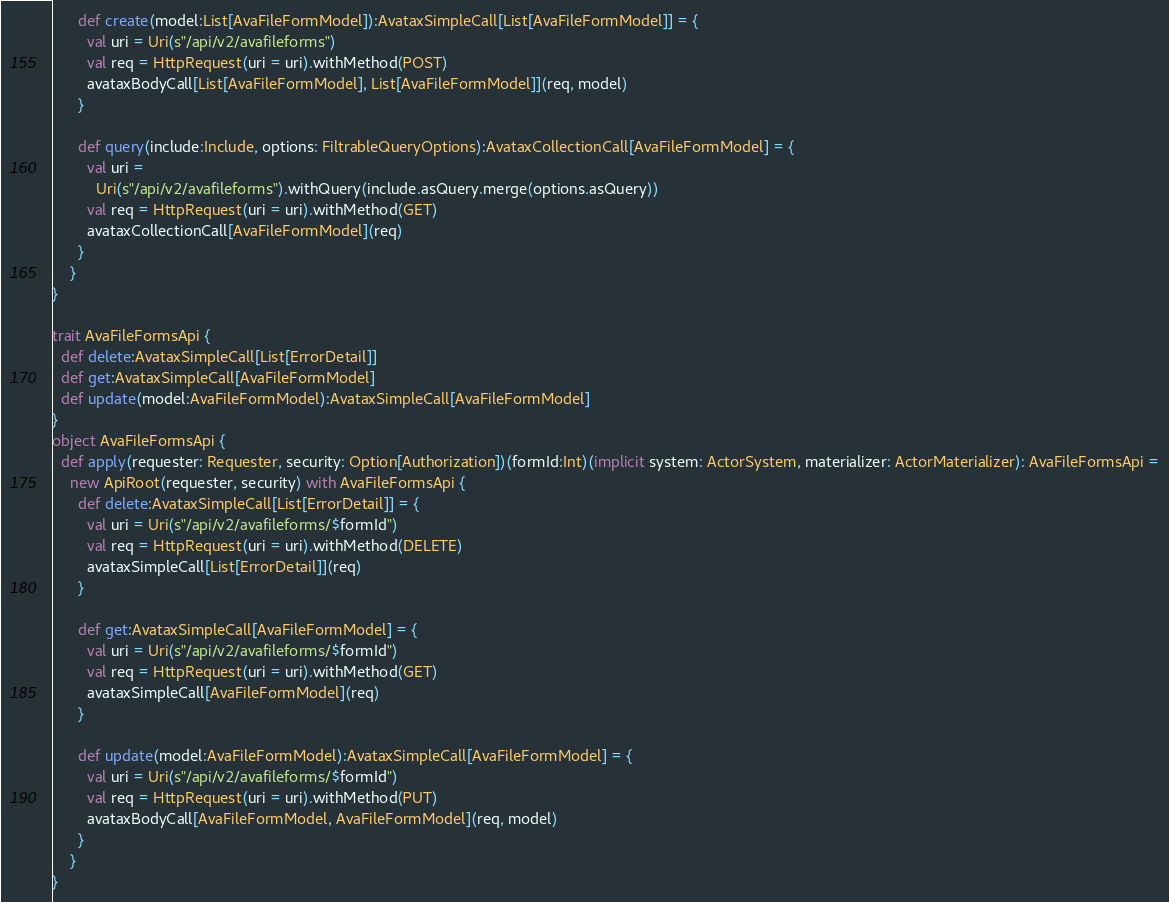<code> <loc_0><loc_0><loc_500><loc_500><_Scala_>      def create(model:List[AvaFileFormModel]):AvataxSimpleCall[List[AvaFileFormModel]] = {
        val uri = Uri(s"/api/v2/avafileforms")
        val req = HttpRequest(uri = uri).withMethod(POST)
        avataxBodyCall[List[AvaFileFormModel], List[AvaFileFormModel]](req, model)
      }

      def query(include:Include, options: FiltrableQueryOptions):AvataxCollectionCall[AvaFileFormModel] = {
        val uri =
          Uri(s"/api/v2/avafileforms").withQuery(include.asQuery.merge(options.asQuery))
        val req = HttpRequest(uri = uri).withMethod(GET)
        avataxCollectionCall[AvaFileFormModel](req)
      }
    }
}

trait AvaFileFormsApi {
  def delete:AvataxSimpleCall[List[ErrorDetail]]
  def get:AvataxSimpleCall[AvaFileFormModel]
  def update(model:AvaFileFormModel):AvataxSimpleCall[AvaFileFormModel]
}
object AvaFileFormsApi {
  def apply(requester: Requester, security: Option[Authorization])(formId:Int)(implicit system: ActorSystem, materializer: ActorMaterializer): AvaFileFormsApi =
    new ApiRoot(requester, security) with AvaFileFormsApi {
      def delete:AvataxSimpleCall[List[ErrorDetail]] = {
        val uri = Uri(s"/api/v2/avafileforms/$formId")
        val req = HttpRequest(uri = uri).withMethod(DELETE)
        avataxSimpleCall[List[ErrorDetail]](req)
      }

      def get:AvataxSimpleCall[AvaFileFormModel] = {
        val uri = Uri(s"/api/v2/avafileforms/$formId")
        val req = HttpRequest(uri = uri).withMethod(GET)
        avataxSimpleCall[AvaFileFormModel](req)
      }

      def update(model:AvaFileFormModel):AvataxSimpleCall[AvaFileFormModel] = {
        val uri = Uri(s"/api/v2/avafileforms/$formId")
        val req = HttpRequest(uri = uri).withMethod(PUT)
        avataxBodyCall[AvaFileFormModel, AvaFileFormModel](req, model)
      }
    }
}
</code> 